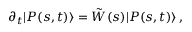<formula> <loc_0><loc_0><loc_500><loc_500>\partial _ { t } | P ( s , t ) \rangle = \tilde { W } ( s ) | P ( s , t ) \rangle \, ,</formula> 